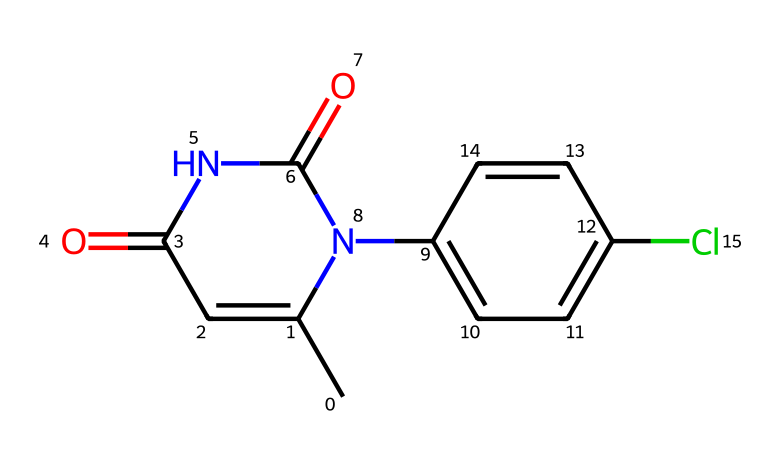What is the functional group present in this chemical? The chemical structure includes a carbonyl group (C=O) indicated by the double bond to oxygen, which is characteristic of amides and can be seen at the NC(=O) and CC(=O) locations.
Answer: carbonyl How many rings are present in this structure? The chemical structure contains two cyclic structures: one is a five-membered ring (1,3-diazole) and the other is a six-membered aromatic ring (phenyl).
Answer: two What type of herbicide is this likely categorized as? Based on the structure, it shows characteristics typical of selective herbicides which target specific weed types without harming crops.
Answer: selective herbicide What is the unique halogen substituent in this compound? The structure includes a chlorine atom (Cl) attached to the aromatic ring, which is noted in the substitution pattern of the benzene.
Answer: chlorine How many nitrogen atoms are in this chemical? By examining the structural depiction, we can identify two nitrogen atoms present in the chemical, both of which are involved in the amide linkage.
Answer: two What is the main purpose of the carbonyl group in herbicides like this? The carbonyl group contributes to the herbicide's selectivity and effectiveness by participating in interactions with specific target enzymes or proteins in the plants.
Answer: selectivity 